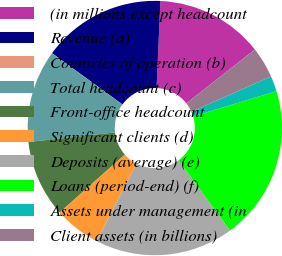<chart> <loc_0><loc_0><loc_500><loc_500><pie_chart><fcel>(in millions except headcount<fcel>Revenue (a)<fcel>Countries of operation (b)<fcel>Total headcount (c)<fcel>Front-office headcount<fcel>Significant clients (d)<fcel>Deposits (average) (e)<fcel>Loans (period-end) (f)<fcel>Assets under management (in<fcel>Client assets (in billions)<nl><fcel>13.72%<fcel>15.68%<fcel>0.01%<fcel>11.76%<fcel>9.8%<fcel>5.88%<fcel>17.64%<fcel>19.6%<fcel>1.97%<fcel>3.93%<nl></chart> 